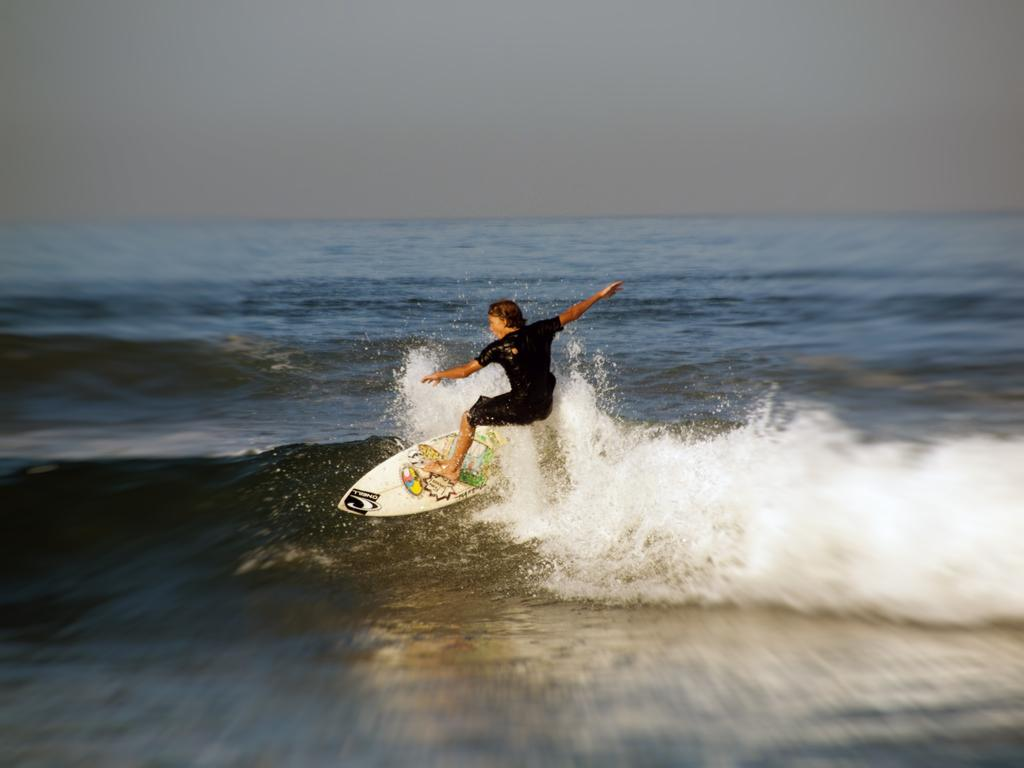What is the person in the image doing? The person is surfing. What tool or equipment is the person using to surf? The person is using a surfboard. Where is the person located in the image? The person is on the water. What is visible at the top of the image? The sky is visible at the top of the image. What type of cake is the person eating while surfing in the image? There is no cake present in the image; the person is surfing on a surfboard. 